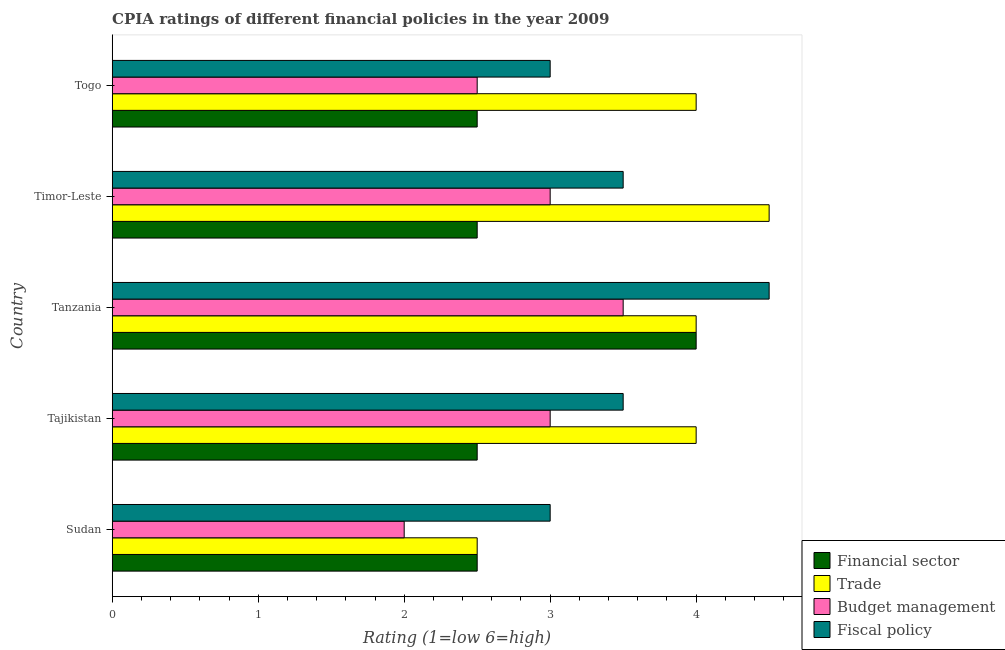How many different coloured bars are there?
Keep it short and to the point. 4. How many groups of bars are there?
Offer a very short reply. 5. Are the number of bars per tick equal to the number of legend labels?
Offer a very short reply. Yes. Are the number of bars on each tick of the Y-axis equal?
Your response must be concise. Yes. What is the label of the 4th group of bars from the top?
Your answer should be very brief. Tajikistan. What is the cpia rating of trade in Sudan?
Provide a succinct answer. 2.5. Across all countries, what is the minimum cpia rating of fiscal policy?
Your answer should be very brief. 3. In which country was the cpia rating of budget management maximum?
Provide a succinct answer. Tanzania. In which country was the cpia rating of trade minimum?
Keep it short and to the point. Sudan. What is the total cpia rating of fiscal policy in the graph?
Ensure brevity in your answer.  17.5. In how many countries, is the cpia rating of fiscal policy greater than 1.6 ?
Your answer should be compact. 5. What is the ratio of the cpia rating of fiscal policy in Timor-Leste to that in Togo?
Offer a terse response. 1.17. Is the cpia rating of financial sector in Tajikistan less than that in Togo?
Offer a terse response. No. Is the difference between the cpia rating of fiscal policy in Tanzania and Timor-Leste greater than the difference between the cpia rating of budget management in Tanzania and Timor-Leste?
Your answer should be very brief. Yes. What is the difference between the highest and the lowest cpia rating of trade?
Your answer should be very brief. 2. In how many countries, is the cpia rating of trade greater than the average cpia rating of trade taken over all countries?
Offer a very short reply. 4. Is the sum of the cpia rating of trade in Sudan and Togo greater than the maximum cpia rating of fiscal policy across all countries?
Provide a short and direct response. Yes. Is it the case that in every country, the sum of the cpia rating of budget management and cpia rating of fiscal policy is greater than the sum of cpia rating of financial sector and cpia rating of trade?
Offer a terse response. No. What does the 3rd bar from the top in Timor-Leste represents?
Offer a very short reply. Trade. What does the 4th bar from the bottom in Tanzania represents?
Ensure brevity in your answer.  Fiscal policy. How many bars are there?
Your answer should be compact. 20. Are all the bars in the graph horizontal?
Your answer should be very brief. Yes. How many countries are there in the graph?
Give a very brief answer. 5. Does the graph contain any zero values?
Give a very brief answer. No. Does the graph contain grids?
Offer a terse response. No. Where does the legend appear in the graph?
Keep it short and to the point. Bottom right. How many legend labels are there?
Offer a very short reply. 4. How are the legend labels stacked?
Keep it short and to the point. Vertical. What is the title of the graph?
Offer a very short reply. CPIA ratings of different financial policies in the year 2009. What is the label or title of the X-axis?
Your answer should be compact. Rating (1=low 6=high). What is the Rating (1=low 6=high) in Financial sector in Sudan?
Provide a succinct answer. 2.5. What is the Rating (1=low 6=high) of Financial sector in Tajikistan?
Your answer should be very brief. 2.5. What is the Rating (1=low 6=high) of Fiscal policy in Tajikistan?
Provide a short and direct response. 3.5. What is the Rating (1=low 6=high) in Fiscal policy in Tanzania?
Provide a short and direct response. 4.5. What is the Rating (1=low 6=high) of Fiscal policy in Timor-Leste?
Your answer should be compact. 3.5. Across all countries, what is the maximum Rating (1=low 6=high) of Fiscal policy?
Provide a short and direct response. 4.5. Across all countries, what is the minimum Rating (1=low 6=high) in Trade?
Give a very brief answer. 2.5. Across all countries, what is the minimum Rating (1=low 6=high) of Budget management?
Keep it short and to the point. 2. What is the total Rating (1=low 6=high) of Financial sector in the graph?
Offer a terse response. 14. What is the total Rating (1=low 6=high) of Fiscal policy in the graph?
Give a very brief answer. 17.5. What is the difference between the Rating (1=low 6=high) of Financial sector in Sudan and that in Tajikistan?
Your answer should be very brief. 0. What is the difference between the Rating (1=low 6=high) of Trade in Sudan and that in Tajikistan?
Offer a terse response. -1.5. What is the difference between the Rating (1=low 6=high) of Fiscal policy in Sudan and that in Tajikistan?
Offer a very short reply. -0.5. What is the difference between the Rating (1=low 6=high) in Financial sector in Sudan and that in Tanzania?
Provide a short and direct response. -1.5. What is the difference between the Rating (1=low 6=high) of Trade in Sudan and that in Tanzania?
Offer a very short reply. -1.5. What is the difference between the Rating (1=low 6=high) in Trade in Sudan and that in Timor-Leste?
Provide a succinct answer. -2. What is the difference between the Rating (1=low 6=high) in Budget management in Sudan and that in Timor-Leste?
Keep it short and to the point. -1. What is the difference between the Rating (1=low 6=high) of Fiscal policy in Sudan and that in Timor-Leste?
Your answer should be very brief. -0.5. What is the difference between the Rating (1=low 6=high) in Fiscal policy in Sudan and that in Togo?
Provide a short and direct response. 0. What is the difference between the Rating (1=low 6=high) of Financial sector in Tajikistan and that in Tanzania?
Provide a succinct answer. -1.5. What is the difference between the Rating (1=low 6=high) of Trade in Tajikistan and that in Tanzania?
Offer a very short reply. 0. What is the difference between the Rating (1=low 6=high) in Trade in Tajikistan and that in Timor-Leste?
Ensure brevity in your answer.  -0.5. What is the difference between the Rating (1=low 6=high) of Fiscal policy in Tajikistan and that in Timor-Leste?
Ensure brevity in your answer.  0. What is the difference between the Rating (1=low 6=high) in Financial sector in Tajikistan and that in Togo?
Make the answer very short. 0. What is the difference between the Rating (1=low 6=high) of Fiscal policy in Tajikistan and that in Togo?
Give a very brief answer. 0.5. What is the difference between the Rating (1=low 6=high) of Financial sector in Tanzania and that in Timor-Leste?
Make the answer very short. 1.5. What is the difference between the Rating (1=low 6=high) in Trade in Tanzania and that in Timor-Leste?
Your answer should be compact. -0.5. What is the difference between the Rating (1=low 6=high) of Fiscal policy in Tanzania and that in Timor-Leste?
Provide a short and direct response. 1. What is the difference between the Rating (1=low 6=high) of Fiscal policy in Tanzania and that in Togo?
Keep it short and to the point. 1.5. What is the difference between the Rating (1=low 6=high) in Financial sector in Timor-Leste and that in Togo?
Your answer should be compact. 0. What is the difference between the Rating (1=low 6=high) of Trade in Timor-Leste and that in Togo?
Offer a very short reply. 0.5. What is the difference between the Rating (1=low 6=high) of Financial sector in Sudan and the Rating (1=low 6=high) of Fiscal policy in Tajikistan?
Your answer should be compact. -1. What is the difference between the Rating (1=low 6=high) of Budget management in Sudan and the Rating (1=low 6=high) of Fiscal policy in Tajikistan?
Your response must be concise. -1.5. What is the difference between the Rating (1=low 6=high) of Financial sector in Sudan and the Rating (1=low 6=high) of Trade in Tanzania?
Your answer should be compact. -1.5. What is the difference between the Rating (1=low 6=high) of Financial sector in Sudan and the Rating (1=low 6=high) of Fiscal policy in Tanzania?
Offer a very short reply. -2. What is the difference between the Rating (1=low 6=high) in Trade in Sudan and the Rating (1=low 6=high) in Budget management in Tanzania?
Your response must be concise. -1. What is the difference between the Rating (1=low 6=high) in Trade in Sudan and the Rating (1=low 6=high) in Fiscal policy in Tanzania?
Your answer should be compact. -2. What is the difference between the Rating (1=low 6=high) in Budget management in Sudan and the Rating (1=low 6=high) in Fiscal policy in Tanzania?
Provide a succinct answer. -2.5. What is the difference between the Rating (1=low 6=high) in Financial sector in Sudan and the Rating (1=low 6=high) in Budget management in Timor-Leste?
Keep it short and to the point. -0.5. What is the difference between the Rating (1=low 6=high) of Financial sector in Sudan and the Rating (1=low 6=high) of Fiscal policy in Timor-Leste?
Provide a short and direct response. -1. What is the difference between the Rating (1=low 6=high) in Trade in Sudan and the Rating (1=low 6=high) in Budget management in Timor-Leste?
Your answer should be compact. -0.5. What is the difference between the Rating (1=low 6=high) of Financial sector in Sudan and the Rating (1=low 6=high) of Trade in Togo?
Your response must be concise. -1.5. What is the difference between the Rating (1=low 6=high) of Financial sector in Sudan and the Rating (1=low 6=high) of Budget management in Togo?
Offer a terse response. 0. What is the difference between the Rating (1=low 6=high) in Financial sector in Sudan and the Rating (1=low 6=high) in Fiscal policy in Togo?
Provide a short and direct response. -0.5. What is the difference between the Rating (1=low 6=high) of Trade in Sudan and the Rating (1=low 6=high) of Budget management in Togo?
Your answer should be very brief. 0. What is the difference between the Rating (1=low 6=high) in Budget management in Sudan and the Rating (1=low 6=high) in Fiscal policy in Togo?
Your response must be concise. -1. What is the difference between the Rating (1=low 6=high) of Financial sector in Tajikistan and the Rating (1=low 6=high) of Trade in Tanzania?
Ensure brevity in your answer.  -1.5. What is the difference between the Rating (1=low 6=high) of Financial sector in Tajikistan and the Rating (1=low 6=high) of Fiscal policy in Tanzania?
Your response must be concise. -2. What is the difference between the Rating (1=low 6=high) of Budget management in Tajikistan and the Rating (1=low 6=high) of Fiscal policy in Tanzania?
Ensure brevity in your answer.  -1.5. What is the difference between the Rating (1=low 6=high) in Financial sector in Tajikistan and the Rating (1=low 6=high) in Budget management in Timor-Leste?
Your answer should be compact. -0.5. What is the difference between the Rating (1=low 6=high) in Financial sector in Tajikistan and the Rating (1=low 6=high) in Fiscal policy in Timor-Leste?
Provide a short and direct response. -1. What is the difference between the Rating (1=low 6=high) of Budget management in Tajikistan and the Rating (1=low 6=high) of Fiscal policy in Timor-Leste?
Make the answer very short. -0.5. What is the difference between the Rating (1=low 6=high) of Financial sector in Tajikistan and the Rating (1=low 6=high) of Trade in Togo?
Your response must be concise. -1.5. What is the difference between the Rating (1=low 6=high) in Trade in Tajikistan and the Rating (1=low 6=high) in Fiscal policy in Togo?
Your answer should be compact. 1. What is the difference between the Rating (1=low 6=high) in Financial sector in Tanzania and the Rating (1=low 6=high) in Budget management in Timor-Leste?
Provide a short and direct response. 1. What is the difference between the Rating (1=low 6=high) in Financial sector in Tanzania and the Rating (1=low 6=high) in Fiscal policy in Timor-Leste?
Offer a terse response. 0.5. What is the difference between the Rating (1=low 6=high) of Trade in Tanzania and the Rating (1=low 6=high) of Fiscal policy in Timor-Leste?
Give a very brief answer. 0.5. What is the difference between the Rating (1=low 6=high) in Financial sector in Tanzania and the Rating (1=low 6=high) in Trade in Togo?
Ensure brevity in your answer.  0. What is the difference between the Rating (1=low 6=high) in Financial sector in Tanzania and the Rating (1=low 6=high) in Budget management in Togo?
Give a very brief answer. 1.5. What is the difference between the Rating (1=low 6=high) of Trade in Tanzania and the Rating (1=low 6=high) of Budget management in Togo?
Ensure brevity in your answer.  1.5. What is the difference between the Rating (1=low 6=high) in Financial sector in Timor-Leste and the Rating (1=low 6=high) in Trade in Togo?
Your answer should be very brief. -1.5. What is the difference between the Rating (1=low 6=high) of Financial sector in Timor-Leste and the Rating (1=low 6=high) of Budget management in Togo?
Your response must be concise. 0. What is the difference between the Rating (1=low 6=high) in Trade in Timor-Leste and the Rating (1=low 6=high) in Fiscal policy in Togo?
Keep it short and to the point. 1.5. What is the average Rating (1=low 6=high) of Financial sector per country?
Your response must be concise. 2.8. What is the average Rating (1=low 6=high) in Trade per country?
Your answer should be very brief. 3.8. What is the difference between the Rating (1=low 6=high) in Financial sector and Rating (1=low 6=high) in Budget management in Sudan?
Provide a succinct answer. 0.5. What is the difference between the Rating (1=low 6=high) of Budget management and Rating (1=low 6=high) of Fiscal policy in Sudan?
Offer a terse response. -1. What is the difference between the Rating (1=low 6=high) in Financial sector and Rating (1=low 6=high) in Fiscal policy in Tajikistan?
Provide a short and direct response. -1. What is the difference between the Rating (1=low 6=high) of Trade and Rating (1=low 6=high) of Fiscal policy in Tajikistan?
Provide a succinct answer. 0.5. What is the difference between the Rating (1=low 6=high) of Financial sector and Rating (1=low 6=high) of Budget management in Tanzania?
Give a very brief answer. 0.5. What is the difference between the Rating (1=low 6=high) in Financial sector and Rating (1=low 6=high) in Fiscal policy in Tanzania?
Make the answer very short. -0.5. What is the difference between the Rating (1=low 6=high) of Trade and Rating (1=low 6=high) of Budget management in Tanzania?
Offer a very short reply. 0.5. What is the difference between the Rating (1=low 6=high) of Trade and Rating (1=low 6=high) of Fiscal policy in Tanzania?
Provide a short and direct response. -0.5. What is the difference between the Rating (1=low 6=high) of Financial sector and Rating (1=low 6=high) of Fiscal policy in Timor-Leste?
Keep it short and to the point. -1. What is the difference between the Rating (1=low 6=high) of Trade and Rating (1=low 6=high) of Budget management in Togo?
Make the answer very short. 1.5. What is the ratio of the Rating (1=low 6=high) of Budget management in Sudan to that in Tajikistan?
Make the answer very short. 0.67. What is the ratio of the Rating (1=low 6=high) of Fiscal policy in Sudan to that in Tajikistan?
Offer a terse response. 0.86. What is the ratio of the Rating (1=low 6=high) in Financial sector in Sudan to that in Tanzania?
Ensure brevity in your answer.  0.62. What is the ratio of the Rating (1=low 6=high) in Trade in Sudan to that in Tanzania?
Keep it short and to the point. 0.62. What is the ratio of the Rating (1=low 6=high) of Trade in Sudan to that in Timor-Leste?
Offer a very short reply. 0.56. What is the ratio of the Rating (1=low 6=high) in Trade in Sudan to that in Togo?
Your answer should be very brief. 0.62. What is the ratio of the Rating (1=low 6=high) of Budget management in Sudan to that in Togo?
Your response must be concise. 0.8. What is the ratio of the Rating (1=low 6=high) of Financial sector in Tajikistan to that in Tanzania?
Provide a succinct answer. 0.62. What is the ratio of the Rating (1=low 6=high) of Budget management in Tajikistan to that in Tanzania?
Your response must be concise. 0.86. What is the ratio of the Rating (1=low 6=high) of Fiscal policy in Tajikistan to that in Tanzania?
Ensure brevity in your answer.  0.78. What is the ratio of the Rating (1=low 6=high) in Financial sector in Tajikistan to that in Timor-Leste?
Your response must be concise. 1. What is the ratio of the Rating (1=low 6=high) in Trade in Tajikistan to that in Timor-Leste?
Ensure brevity in your answer.  0.89. What is the ratio of the Rating (1=low 6=high) of Budget management in Tajikistan to that in Timor-Leste?
Your answer should be compact. 1. What is the ratio of the Rating (1=low 6=high) of Budget management in Tajikistan to that in Togo?
Provide a succinct answer. 1.2. What is the ratio of the Rating (1=low 6=high) of Financial sector in Tanzania to that in Timor-Leste?
Your answer should be compact. 1.6. What is the ratio of the Rating (1=low 6=high) of Budget management in Tanzania to that in Timor-Leste?
Provide a succinct answer. 1.17. What is the ratio of the Rating (1=low 6=high) of Financial sector in Tanzania to that in Togo?
Your answer should be very brief. 1.6. What is the ratio of the Rating (1=low 6=high) in Fiscal policy in Tanzania to that in Togo?
Provide a succinct answer. 1.5. What is the ratio of the Rating (1=low 6=high) in Trade in Timor-Leste to that in Togo?
Provide a short and direct response. 1.12. What is the ratio of the Rating (1=low 6=high) of Budget management in Timor-Leste to that in Togo?
Your answer should be compact. 1.2. What is the difference between the highest and the second highest Rating (1=low 6=high) of Financial sector?
Provide a short and direct response. 1.5. What is the difference between the highest and the second highest Rating (1=low 6=high) in Trade?
Provide a short and direct response. 0.5. What is the difference between the highest and the second highest Rating (1=low 6=high) of Budget management?
Ensure brevity in your answer.  0.5. What is the difference between the highest and the lowest Rating (1=low 6=high) in Trade?
Provide a succinct answer. 2. What is the difference between the highest and the lowest Rating (1=low 6=high) of Budget management?
Make the answer very short. 1.5. 